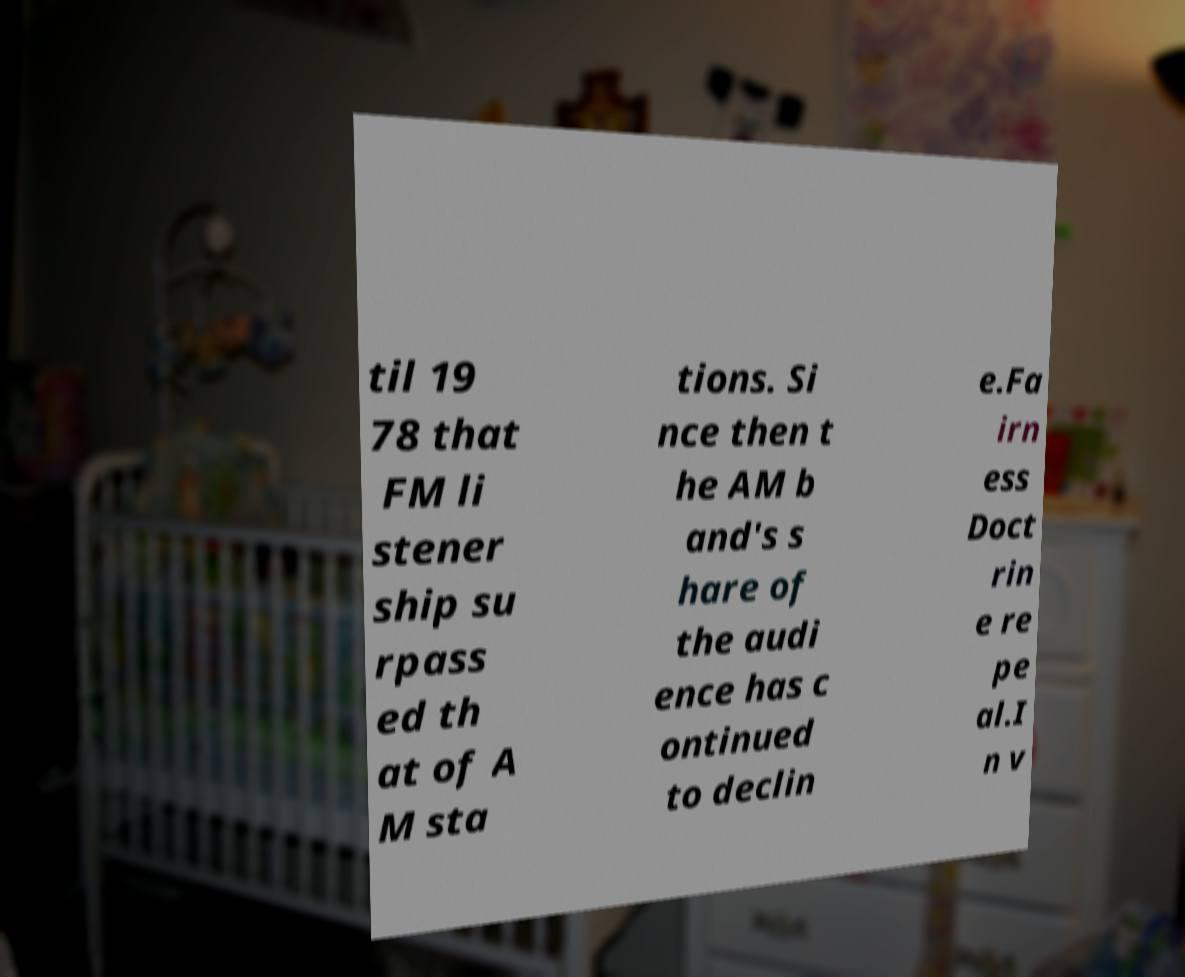What messages or text are displayed in this image? I need them in a readable, typed format. til 19 78 that FM li stener ship su rpass ed th at of A M sta tions. Si nce then t he AM b and's s hare of the audi ence has c ontinued to declin e.Fa irn ess Doct rin e re pe al.I n v 